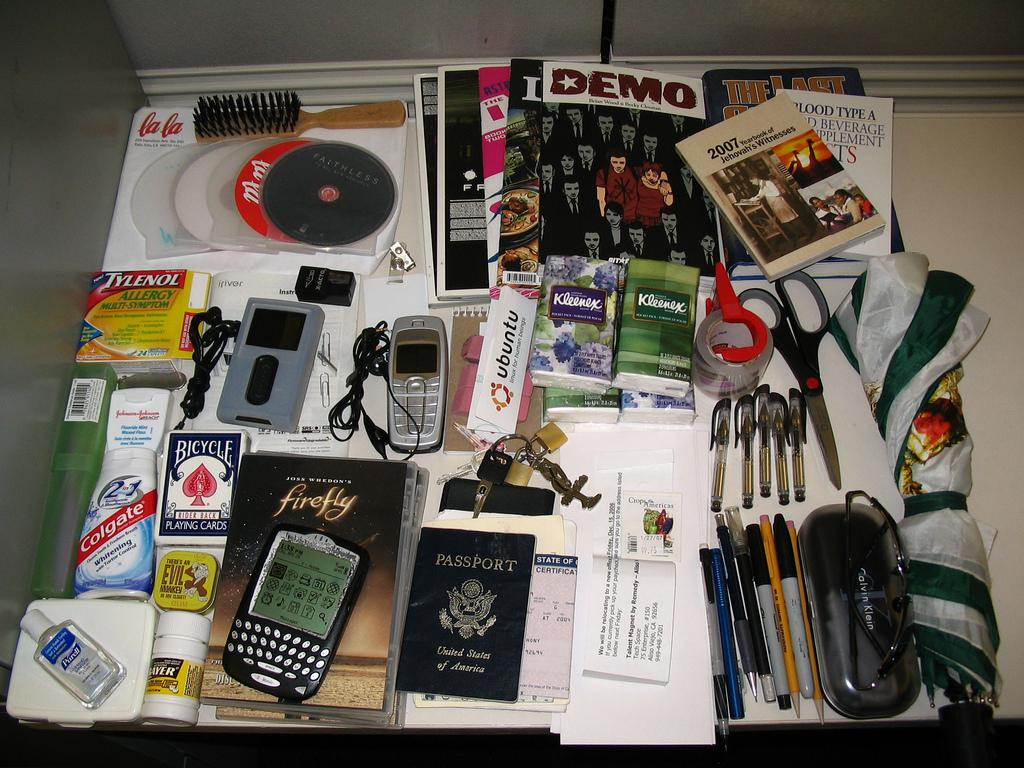Question: how many pens and pencils are there?
Choices:
A. 2.
B. 14.
C. 6.
D. 10.
Answer with the letter. Answer: B Question: where is the packing tape?
Choices:
A. In the garage.
B. In the laundry room.
C. Under the kitchen sink.
D. Next to the kleenex.
Answer with the letter. Answer: D Question: how many decks of cards are there?
Choices:
A. Two.
B. Three.
C. One.
D. Four.
Answer with the letter. Answer: C Question: what is next to the scissors?
Choices:
A. Packing tape in a red dispenser.
B. The tape.
C. A cup.
D. A piece of paper.
Answer with the letter. Answer: A Question: what age is the nokia cell phone?
Choices:
A. New.
B. A little old.
C. Barely used.
D. Old.
Answer with the letter. Answer: D Question: what is next to the bayer aspirin?
Choices:
A. Hand soap.
B. Deodorant.
C. Hand sanitizer.
D. Toothpicks.
Answer with the letter. Answer: C Question: what has a brush, playing cards, a passport, pens, tapes, kleenex, scissors, an umbrella, books, and magazines on it?
Choices:
A. A table.
B. A nightstand.
C. My dresser.
D. The counter.
Answer with the letter. Answer: A Question: how is the stuff laid out?
Choices:
A. Terrible.
B. Horribly.
C. Nice.
D. Neatly.
Answer with the letter. Answer: D Question: what is next to the toothpaste?
Choices:
A. Toothbrush.
B. Crackers.
C. Playing cards.
D. Hair bow.
Answer with the letter. Answer: C Question: how many packages of kleenex are there?
Choices:
A. One.
B. Two.
C. Three.
D. Five.
Answer with the letter. Answer: B Question: where is the passport?
Choices:
A. In the Drawer.
B. By the lamp.
C. The desk.
D. In the man's hand.
Answer with the letter. Answer: C Question: what is over the passport?
Choices:
A. Keys.
B. A hat.
C. Pictures.
D. Lights.
Answer with the letter. Answer: A Question: why will the phone not receive my calls?
Choices:
A. It is broken.
B. The phone is off.
C. It is out of batteries.
D. You are blocked.
Answer with the letter. Answer: B Question: who would use four packs of kleenex?
Choices:
A. A wet dog.
B. A grandma.
C. Someone with a cold.
D. A nurse.
Answer with the letter. Answer: C 